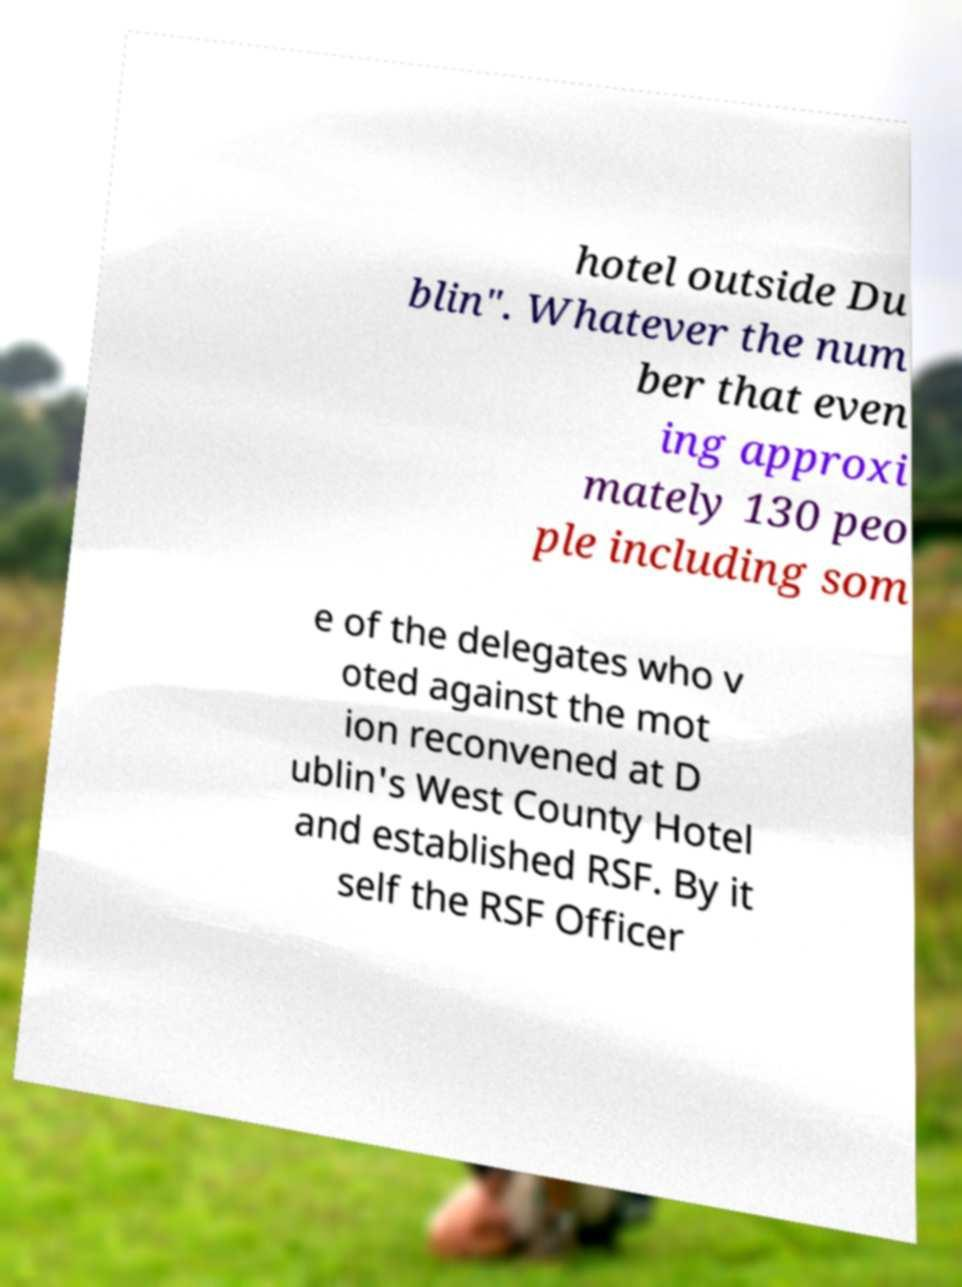Please identify and transcribe the text found in this image. hotel outside Du blin". Whatever the num ber that even ing approxi mately 130 peo ple including som e of the delegates who v oted against the mot ion reconvened at D ublin's West County Hotel and established RSF. By it self the RSF Officer 